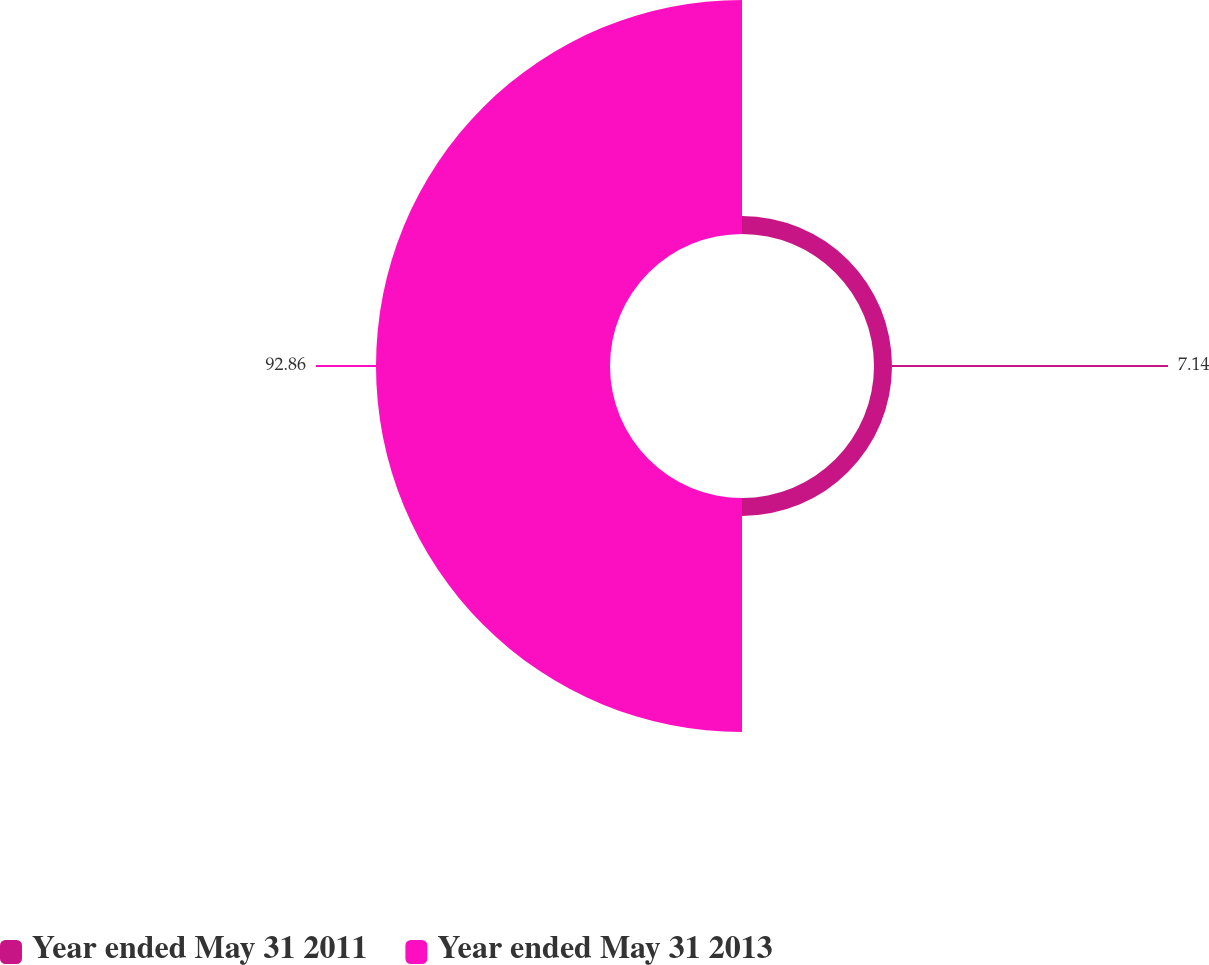Convert chart. <chart><loc_0><loc_0><loc_500><loc_500><pie_chart><fcel>Year ended May 31 2011<fcel>Year ended May 31 2013<nl><fcel>7.14%<fcel>92.86%<nl></chart> 